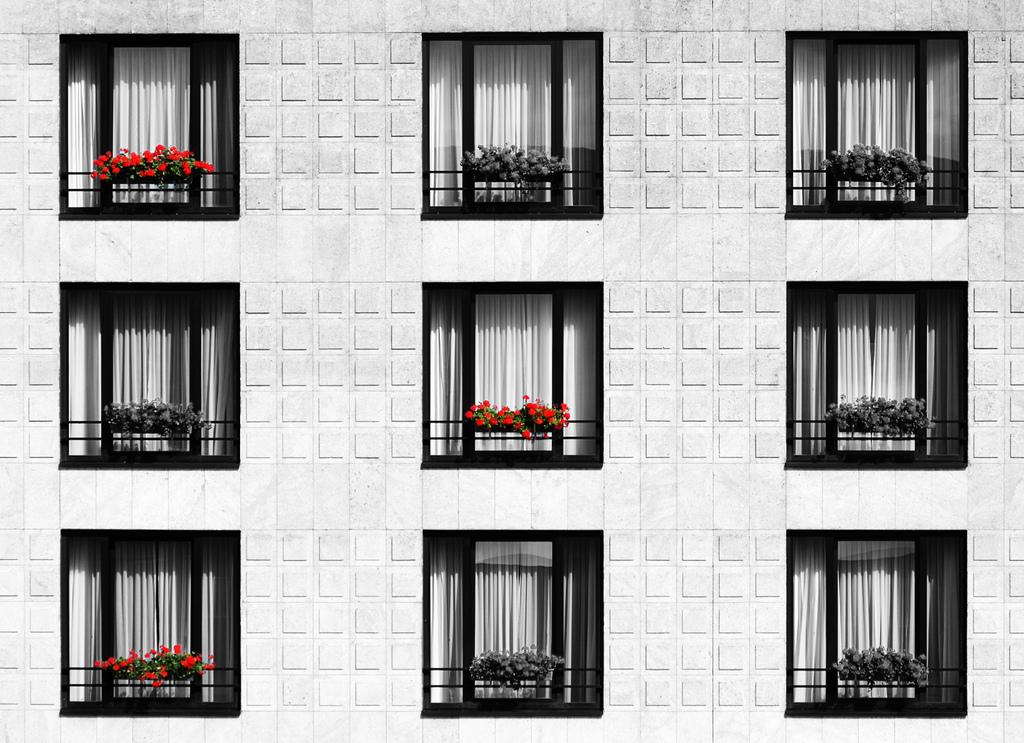What is the main subject of the picture? The main subject of the picture is a building elevation. What features can be seen on the building elevation? The building elevation has windows. Are there any additional details about the windows? Yes, the windows have curtains. What can be seen on the balcony of the building elevation? There are flower pots in the balcony. How far away is the mom from the building in the image? There is no mom present in the image, so it is not possible to determine her distance from the building. 